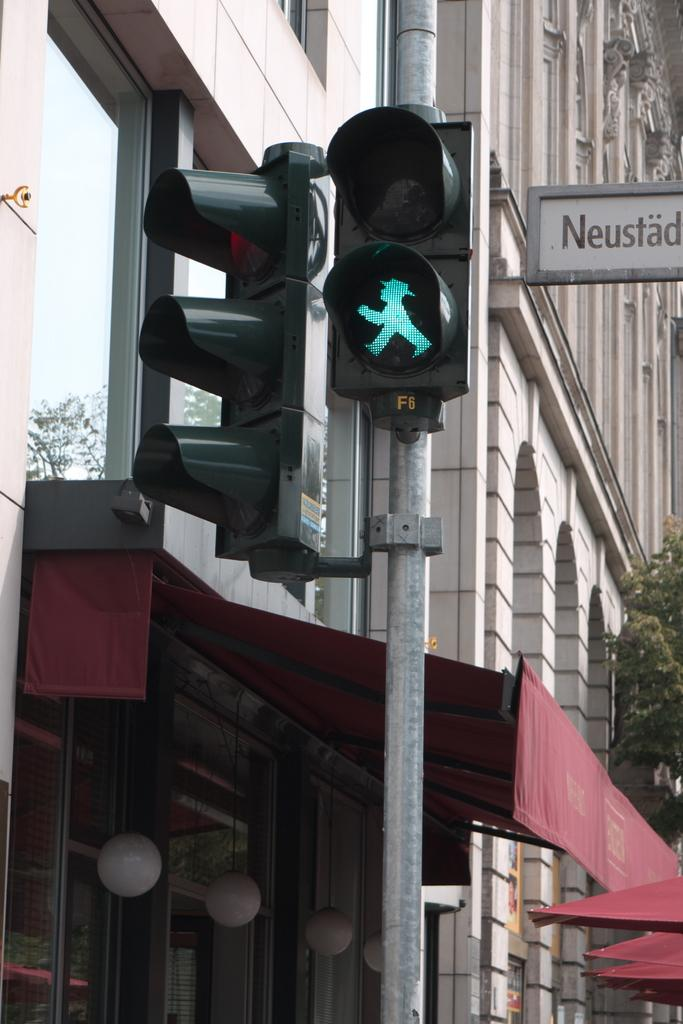What type of structures can be seen in the image? There are buildings in the image. What other man-made objects can be seen in the image? There is a pipeline, sheds, traffic poles, and traffic signals in the image. What natural elements are present in the image? There are trees in the image. Is there any signage or identification in the image? Yes, there is a name board in the image. How much rub can be seen on the pipeline in the image? There is no mention of rub in the image, and the pipeline appears to be clean. What act are the trees performing in the image? Trees are not capable of performing acts; they are stationary plants in the image. 